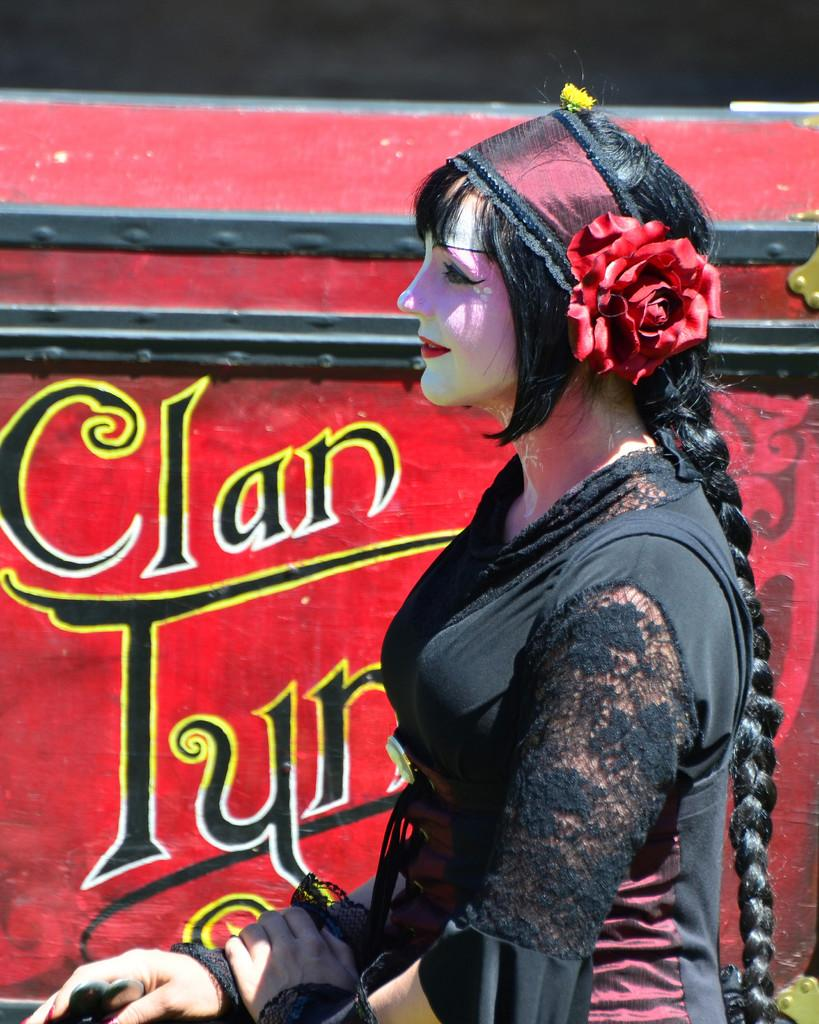Who is the main subject in the foreground of the image? There is a lady in the foreground of the image. What can be seen in the background of the image? There appears to be a poster in the background of the image. What type of prose is being written on the poster in the image? There is no prose visible on the poster in the image. Is there a crayon being used by the lady in the image? There is no crayon present in the image. 